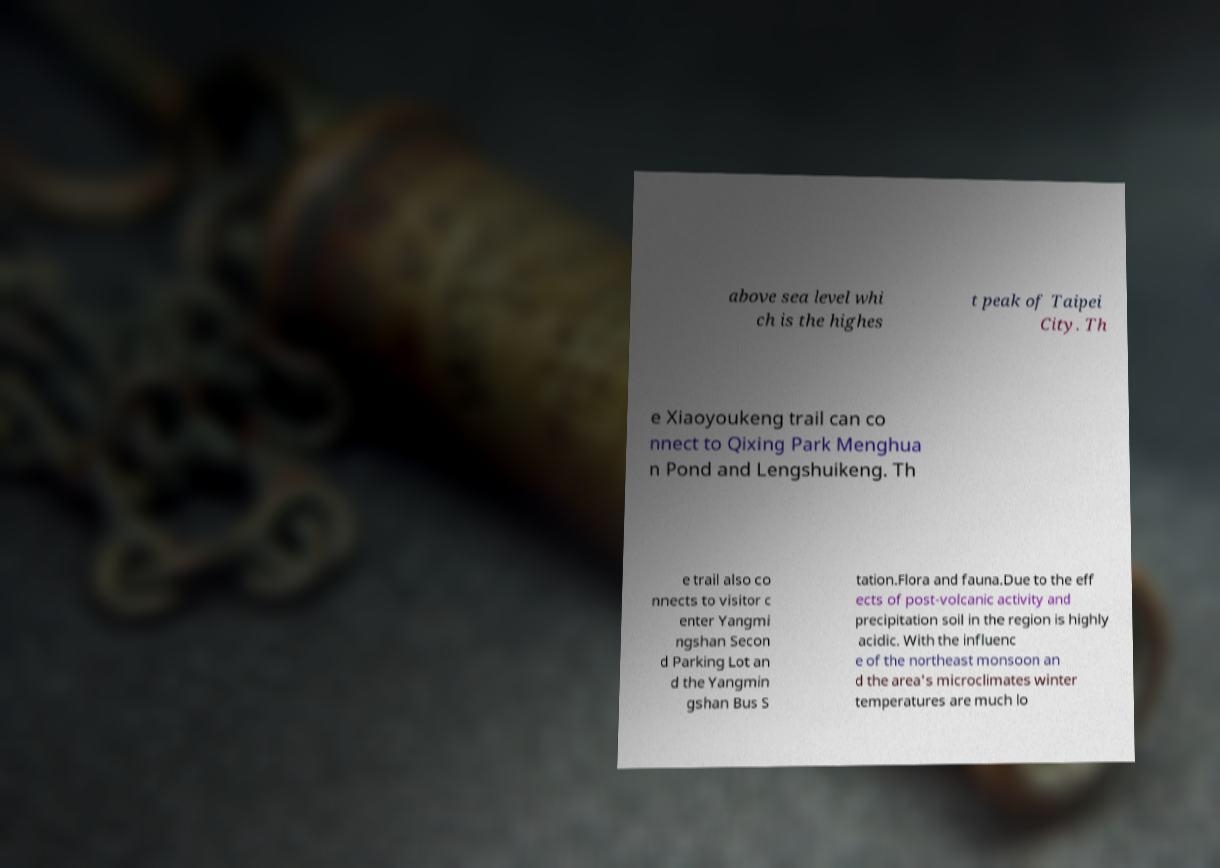Can you accurately transcribe the text from the provided image for me? above sea level whi ch is the highes t peak of Taipei City. Th e Xiaoyoukeng trail can co nnect to Qixing Park Menghua n Pond and Lengshuikeng. Th e trail also co nnects to visitor c enter Yangmi ngshan Secon d Parking Lot an d the Yangmin gshan Bus S tation.Flora and fauna.Due to the eff ects of post-volcanic activity and precipitation soil in the region is highly acidic. With the influenc e of the northeast monsoon an d the area's microclimates winter temperatures are much lo 